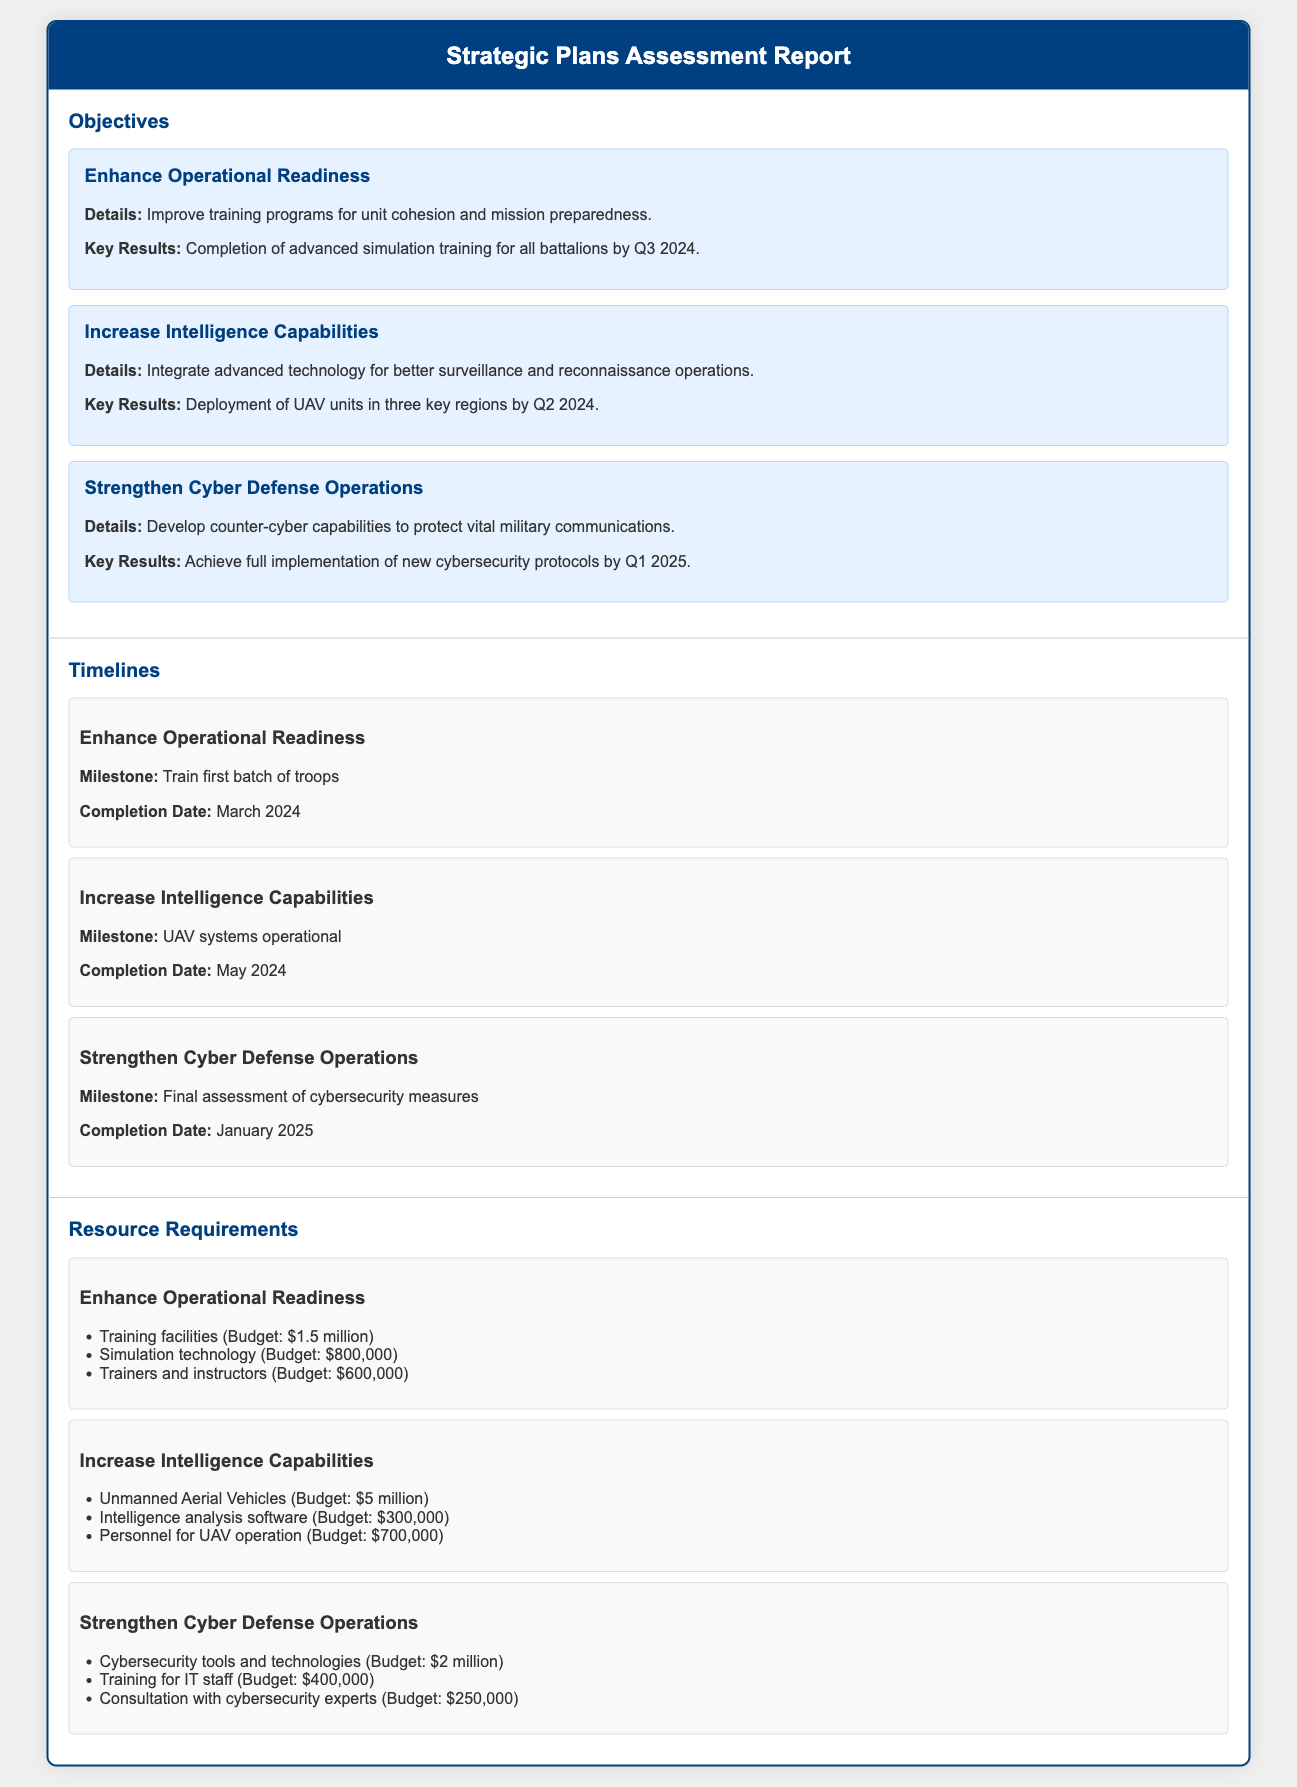What is the completion date for training the first batch of troops? The completion date for training the first batch of troops is stated under timelines for the objective "Enhance Operational Readiness."
Answer: March 2024 What is the budget for Unmanned Aerial Vehicles? The budget for Unmanned Aerial Vehicles is listed under resource requirements for the objective "Increase Intelligence Capabilities."
Answer: $5 million What is the key result for enhancing operational readiness? The key result is specified in the objectives section for "Enhance Operational Readiness."
Answer: Completion of advanced simulation training for all battalions by Q3 2024 What is the milestone for strengthening cyber defense operations? The milestone is provided under the timelines section for the objective "Strengthen Cyber Defense Operations."
Answer: Final assessment of cybersecurity measures What is the total budget for training facilities, simulation technology, and trainers for enhancing operational readiness? The total budget combines the figures stated in the resource requirements for the objective "Enhance Operational Readiness."
Answer: $2.9 million Which objective includes the deployment of UAV units in three key regions? This information is found in the objectives section, outlining various military objectives.
Answer: Increase Intelligence Capabilities When is the completion date for the deployment of UAV systems? The completion date is specified under the timelines section related to the objective "Increase Intelligence Capabilities."
Answer: May 2024 How much is allocated for the training of IT staff under the cyber defense operations? The amount is outlined in the resource requirements for the objective "Strengthen Cyber Defense Operations."
Answer: $400,000 What is the main focus of the objective "Strengthen Cyber Defense Operations"? The primary focus is articulated in the description provided under the objectives section.
Answer: Develop counter-cyber capabilities to protect vital military communications 